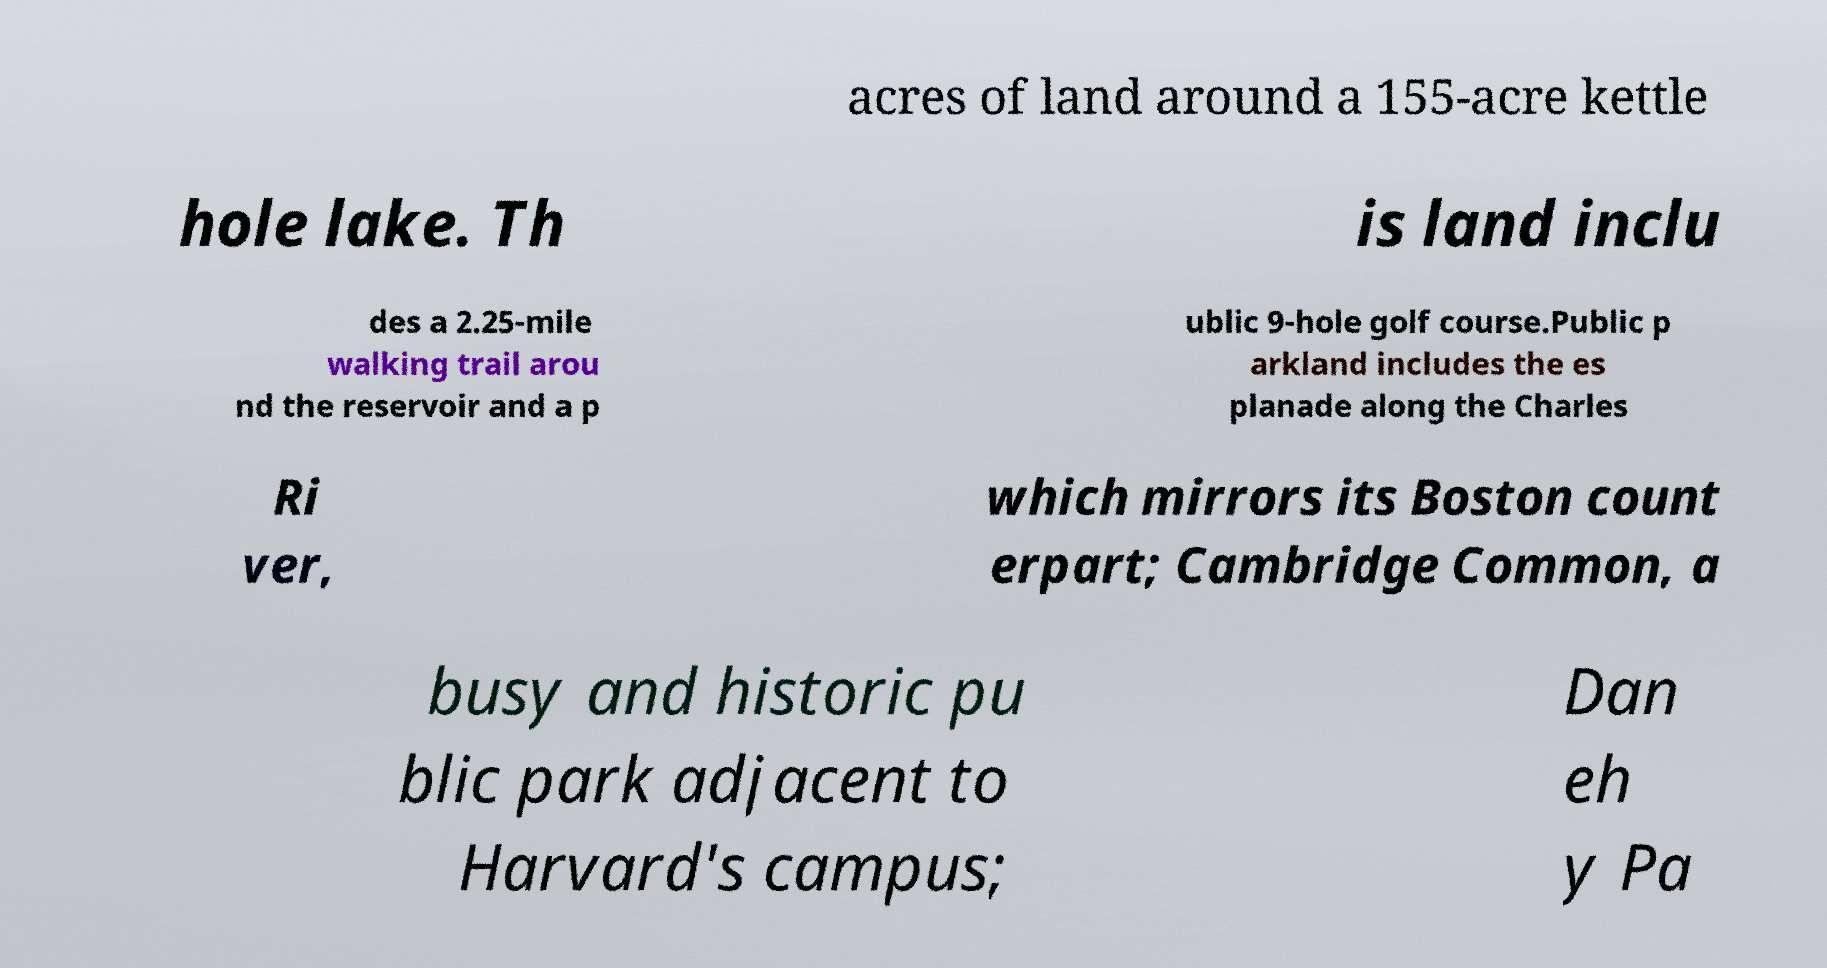Could you extract and type out the text from this image? acres of land around a 155-acre kettle hole lake. Th is land inclu des a 2.25-mile walking trail arou nd the reservoir and a p ublic 9-hole golf course.Public p arkland includes the es planade along the Charles Ri ver, which mirrors its Boston count erpart; Cambridge Common, a busy and historic pu blic park adjacent to Harvard's campus; Dan eh y Pa 